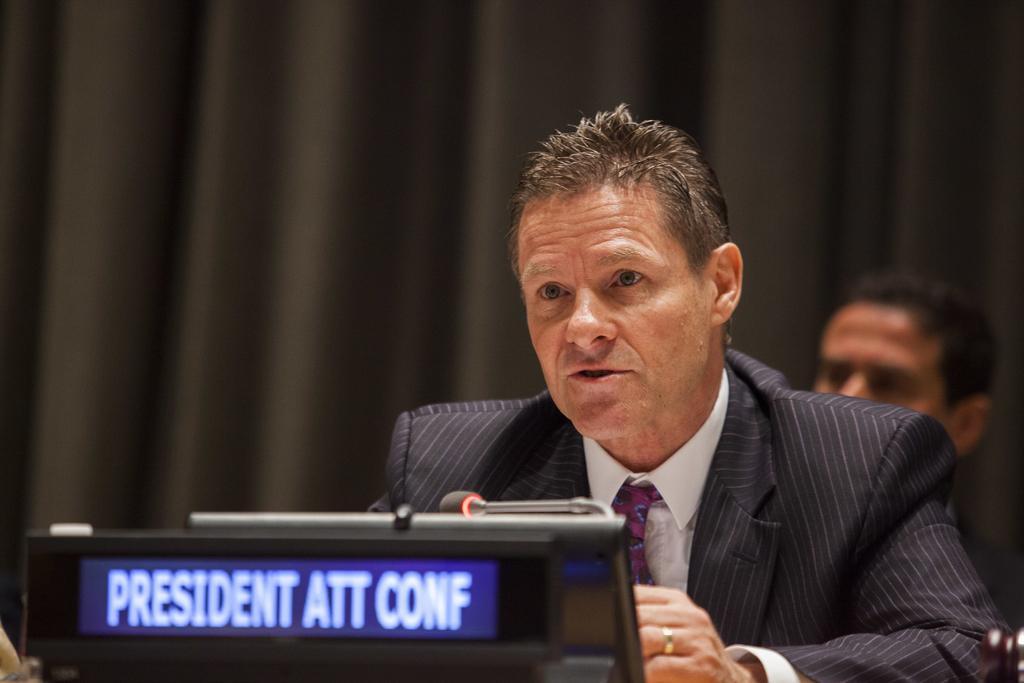Can you describe this image briefly? In this image I see a man who is wearing suit which is of black in color and I see that he is wearing white shirt and a tie and on this screen I see words written and I see a mic over here. In the background I see the black color cloth and I see a man's face over. 